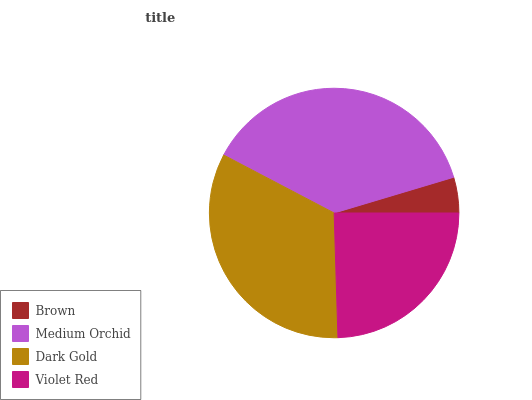Is Brown the minimum?
Answer yes or no. Yes. Is Medium Orchid the maximum?
Answer yes or no. Yes. Is Dark Gold the minimum?
Answer yes or no. No. Is Dark Gold the maximum?
Answer yes or no. No. Is Medium Orchid greater than Dark Gold?
Answer yes or no. Yes. Is Dark Gold less than Medium Orchid?
Answer yes or no. Yes. Is Dark Gold greater than Medium Orchid?
Answer yes or no. No. Is Medium Orchid less than Dark Gold?
Answer yes or no. No. Is Dark Gold the high median?
Answer yes or no. Yes. Is Violet Red the low median?
Answer yes or no. Yes. Is Medium Orchid the high median?
Answer yes or no. No. Is Brown the low median?
Answer yes or no. No. 